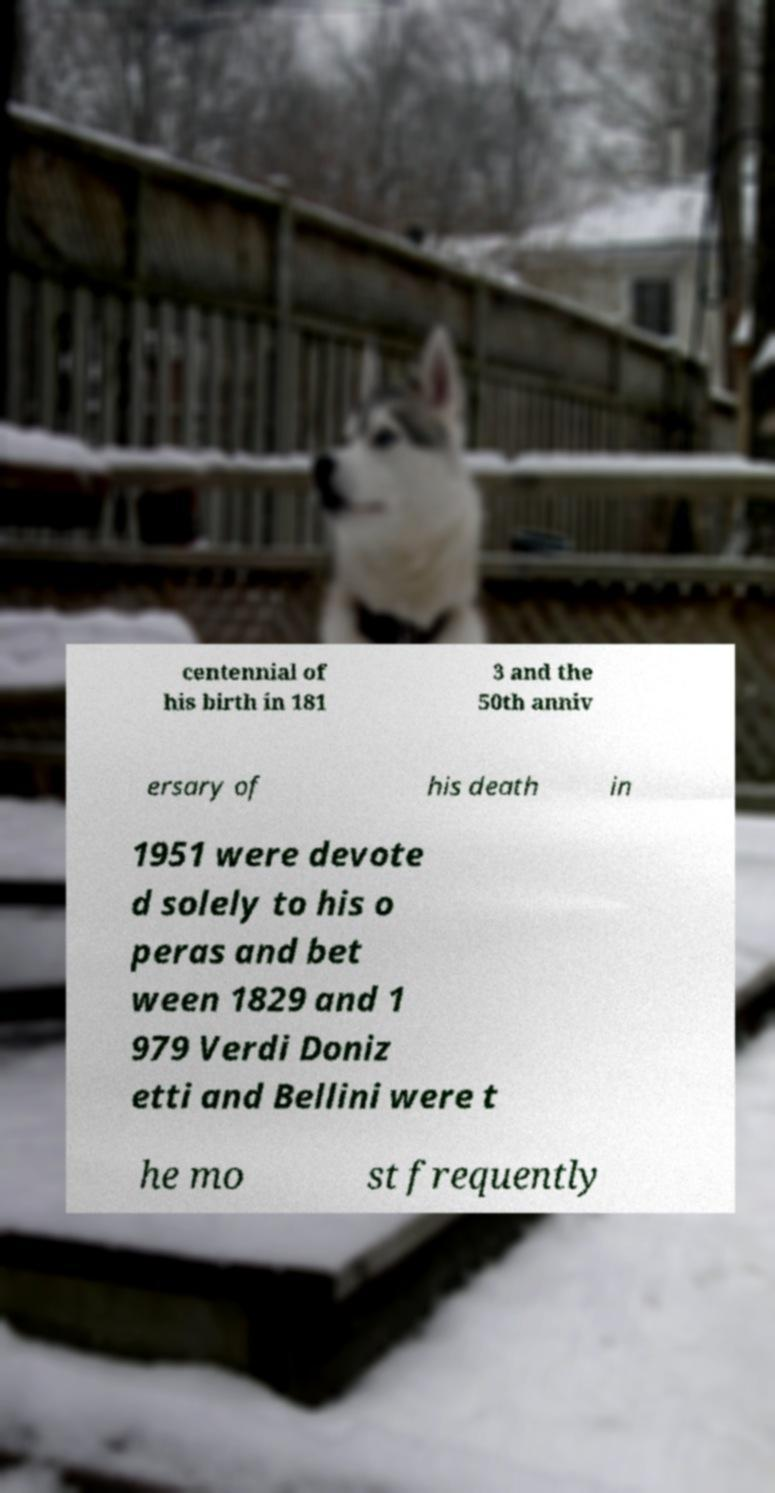Please identify and transcribe the text found in this image. centennial of his birth in 181 3 and the 50th anniv ersary of his death in 1951 were devote d solely to his o peras and bet ween 1829 and 1 979 Verdi Doniz etti and Bellini were t he mo st frequently 